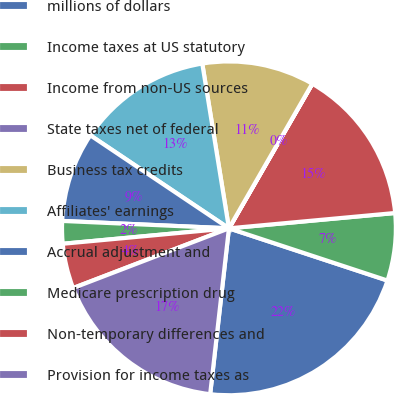Convert chart. <chart><loc_0><loc_0><loc_500><loc_500><pie_chart><fcel>millions of dollars<fcel>Income taxes at US statutory<fcel>Income from non-US sources<fcel>State taxes net of federal<fcel>Business tax credits<fcel>Affiliates' earnings<fcel>Accrual adjustment and<fcel>Medicare prescription drug<fcel>Non-temporary differences and<fcel>Provision for income taxes as<nl><fcel>21.73%<fcel>6.53%<fcel>15.21%<fcel>0.01%<fcel>10.87%<fcel>13.04%<fcel>8.7%<fcel>2.18%<fcel>4.35%<fcel>17.38%<nl></chart> 